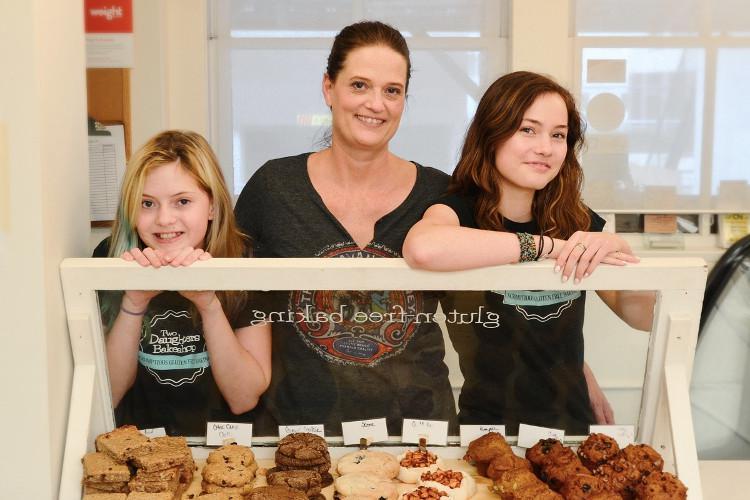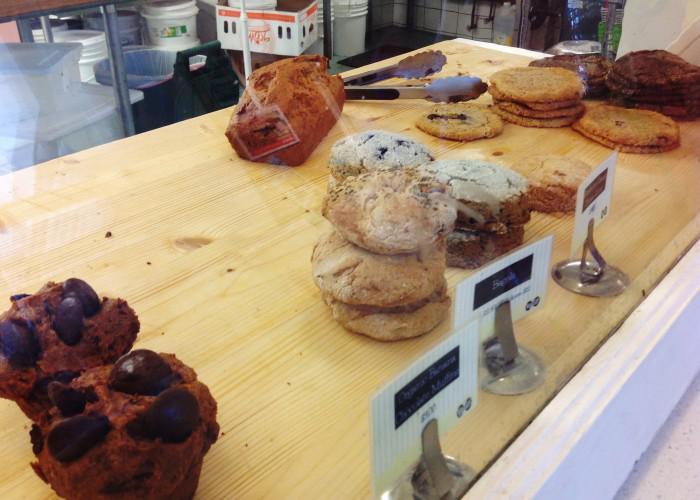The first image is the image on the left, the second image is the image on the right. For the images displayed, is the sentence "One image includes a girl at least on the right of an adult woman, and they are standing behind a rectangle of glass." factually correct? Answer yes or no. Yes. The first image is the image on the left, the second image is the image on the right. Considering the images on both sides, is "The image on the left shows desserts in the foreground and exactly three people." valid? Answer yes or no. Yes. 